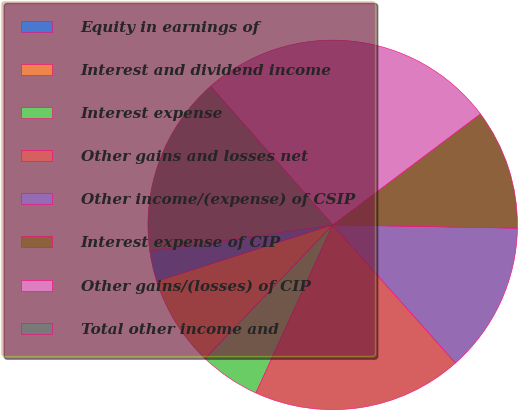Convert chart. <chart><loc_0><loc_0><loc_500><loc_500><pie_chart><fcel>Equity in earnings of<fcel>Interest and dividend income<fcel>Interest expense<fcel>Other gains and losses net<fcel>Other income/(expense) of CSIP<fcel>Interest expense of CIP<fcel>Other gains/(losses) of CIP<fcel>Total other income and<nl><fcel>2.69%<fcel>7.92%<fcel>5.31%<fcel>18.39%<fcel>13.15%<fcel>10.54%<fcel>26.23%<fcel>15.77%<nl></chart> 